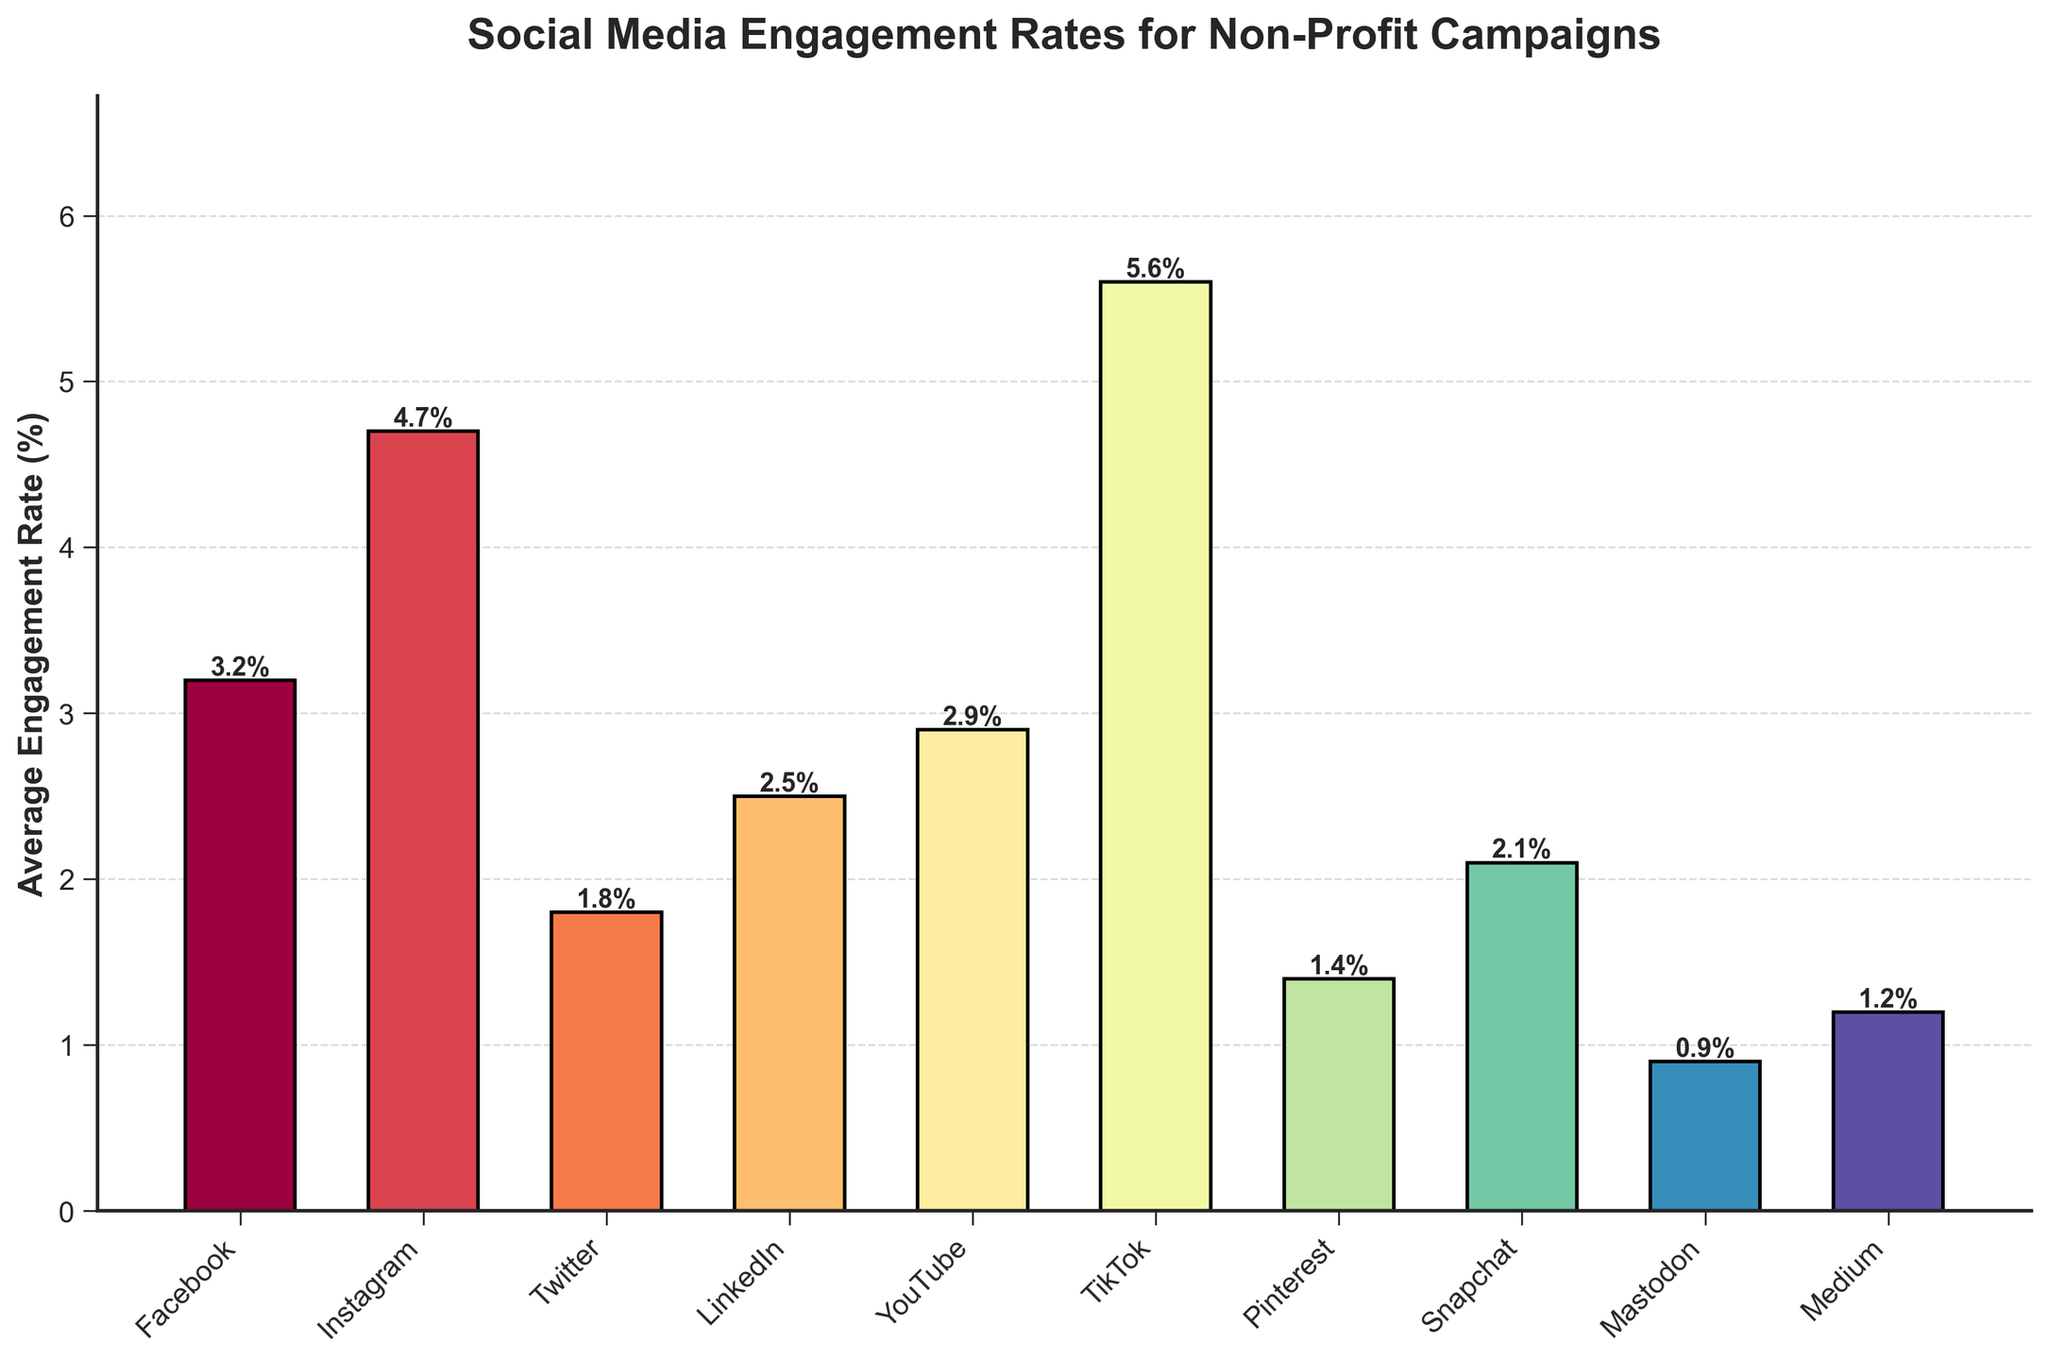Which platform has the highest average engagement rate? Look at the heights of the bars. The highest bar represents the platform with the highest engagement rate. TikTok has the tallest bar.
Answer: TikTok Which platform has the lowest average engagement rate? Look at the heights of the bars. The shortest bar represents the platform with the lowest engagement rate. Mastodon has the shortest bar.
Answer: Mastodon How much higher is TikTok’s engagement rate compared to Facebook’s engagement rate? TikTok’s engagement rate is 5.6%, and Facebook’s is 3.2%. Subtract Facebook's engagement rate from TikTok's. 5.6% - 3.2% = 2.4%
Answer: 2.4% What is the sum of engagement rates for YouTube and Snapchat? YouTube’s engagement rate is 2.9%, and Snapchat's is 2.1%. Add these two rates together. 2.9% + 2.1% = 5.0%
Answer: 5.0% Which platform has a higher engagement rate: Instagram or LinkedIn? Compare the heights of the bars for Instagram and LinkedIn. Instagram's bar is higher.
Answer: Instagram Which platform's bar is colored approximately in the middle of the color spectrum used in the chart? Refer to the color pattern; colors closer to the middle range (not darkest or lightest) represent the central part of the spectrum. LinkedIn has a middle-range color.
Answer: LinkedIn If you were to rank all platforms from highest to lowest in terms of engagement rate, which platform would be third? List the engagement rates in descending order: TikTok, Instagram, Facebook, YouTube, LinkedIn, Snapchat, Twitter, Pinterest, Medium, Mastodon. Facebook is third.
Answer: Facebook What is the difference between the engagement rates of Instagram and Twitter? Instagram’s engagement rate is 4.7%, and Twitter's is 1.8%. Subtract Twitter's engagement rate from Instagram's. 4.7% - 1.8% = 2.9%
Answer: 2.9% How much greater is the average engagement rate of the top platform compared to the bottom platform? TikTok has the highest rate at 5.6%, and Mastodon has the lowest at 0.9%. Subtract the lowest rate from the highest. 5.6% - 0.9% = 4.7%
Answer: 4.7% Which platforms have engagement rates greater than 3%? Check the bars that extend above the 3% mark. These are Facebook, Instagram, TikTok, LinkedIn, and YouTube.
Answer: Facebook, Instagram, TikTok, LinkedIn, YouTube 